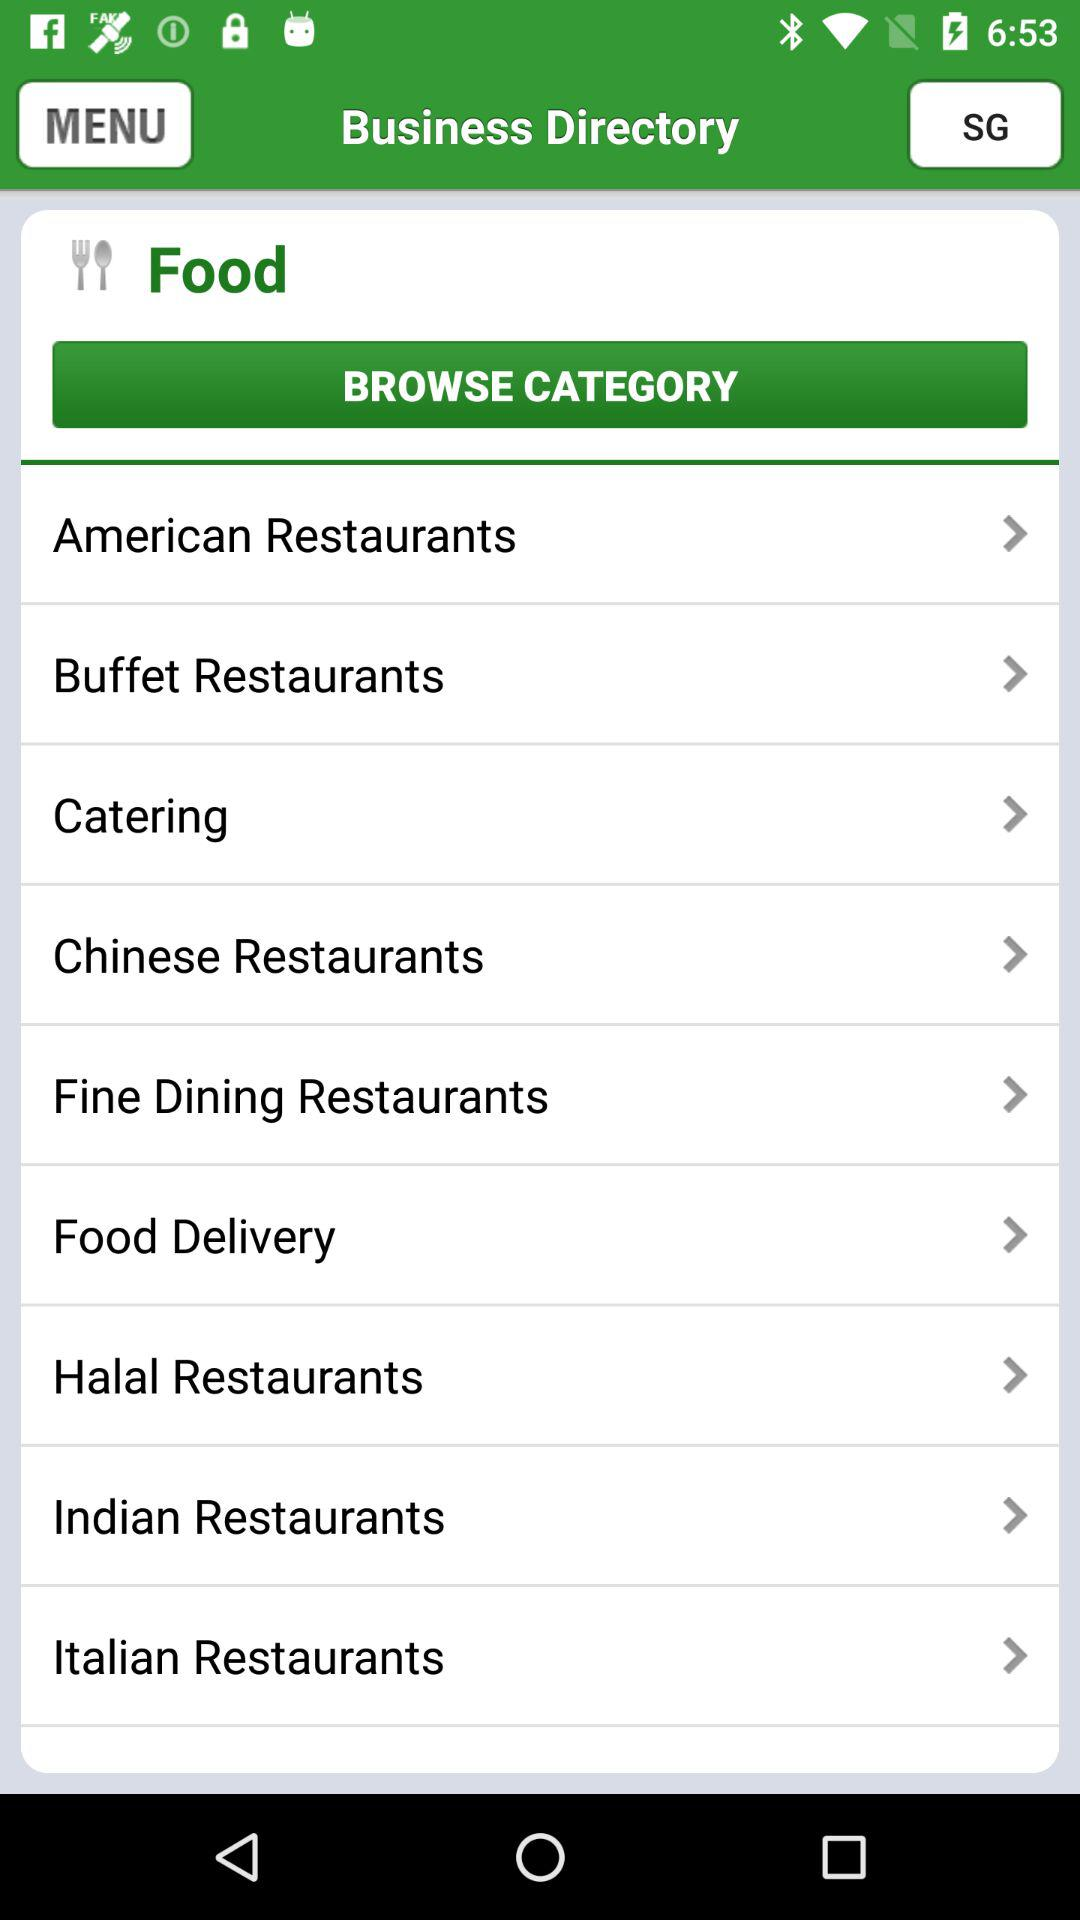What is the application name? The application name is "Business Directory". 